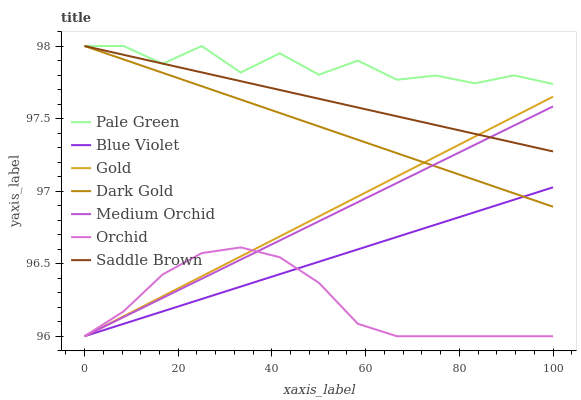Does Orchid have the minimum area under the curve?
Answer yes or no. Yes. Does Pale Green have the maximum area under the curve?
Answer yes or no. Yes. Does Dark Gold have the minimum area under the curve?
Answer yes or no. No. Does Dark Gold have the maximum area under the curve?
Answer yes or no. No. Is Dark Gold the smoothest?
Answer yes or no. Yes. Is Pale Green the roughest?
Answer yes or no. Yes. Is Medium Orchid the smoothest?
Answer yes or no. No. Is Medium Orchid the roughest?
Answer yes or no. No. Does Gold have the lowest value?
Answer yes or no. Yes. Does Dark Gold have the lowest value?
Answer yes or no. No. Does Saddle Brown have the highest value?
Answer yes or no. Yes. Does Medium Orchid have the highest value?
Answer yes or no. No. Is Medium Orchid less than Pale Green?
Answer yes or no. Yes. Is Pale Green greater than Orchid?
Answer yes or no. Yes. Does Orchid intersect Medium Orchid?
Answer yes or no. Yes. Is Orchid less than Medium Orchid?
Answer yes or no. No. Is Orchid greater than Medium Orchid?
Answer yes or no. No. Does Medium Orchid intersect Pale Green?
Answer yes or no. No. 